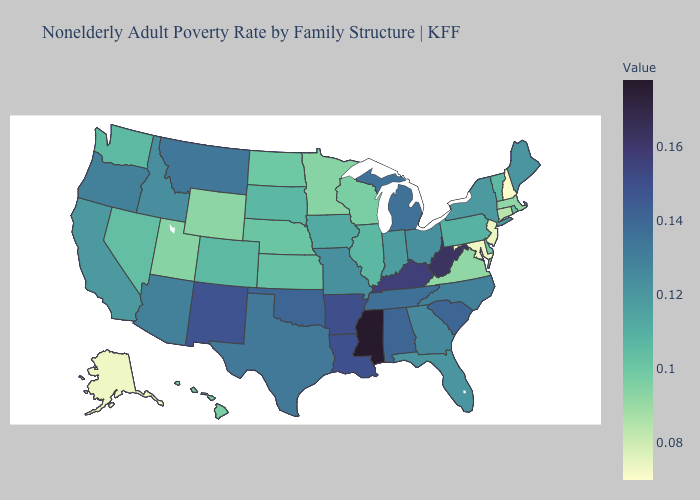Does Mississippi have the highest value in the USA?
Concise answer only. Yes. Which states have the lowest value in the West?
Short answer required. Alaska. Does Tennessee have a lower value than Ohio?
Short answer required. No. Does Mississippi have the highest value in the USA?
Give a very brief answer. Yes. 